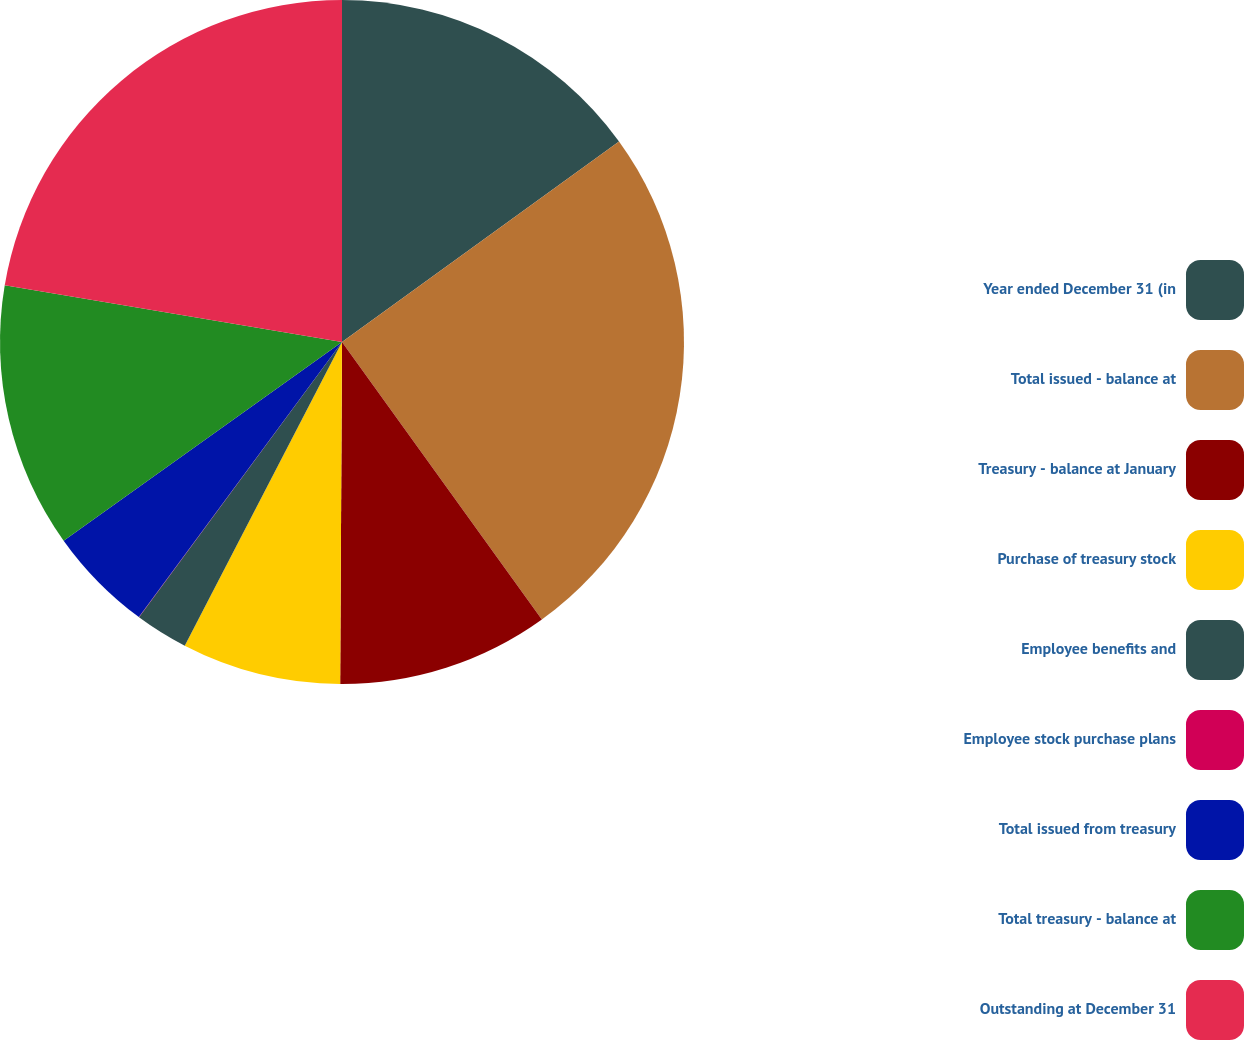Convert chart to OTSL. <chart><loc_0><loc_0><loc_500><loc_500><pie_chart><fcel>Year ended December 31 (in<fcel>Total issued - balance at<fcel>Treasury - balance at January<fcel>Purchase of treasury stock<fcel>Employee benefits and<fcel>Employee stock purchase plans<fcel>Total issued from treasury<fcel>Total treasury - balance at<fcel>Outstanding at December 31<nl><fcel>15.03%<fcel>25.04%<fcel>10.02%<fcel>7.52%<fcel>2.51%<fcel>0.01%<fcel>5.01%<fcel>12.52%<fcel>22.35%<nl></chart> 